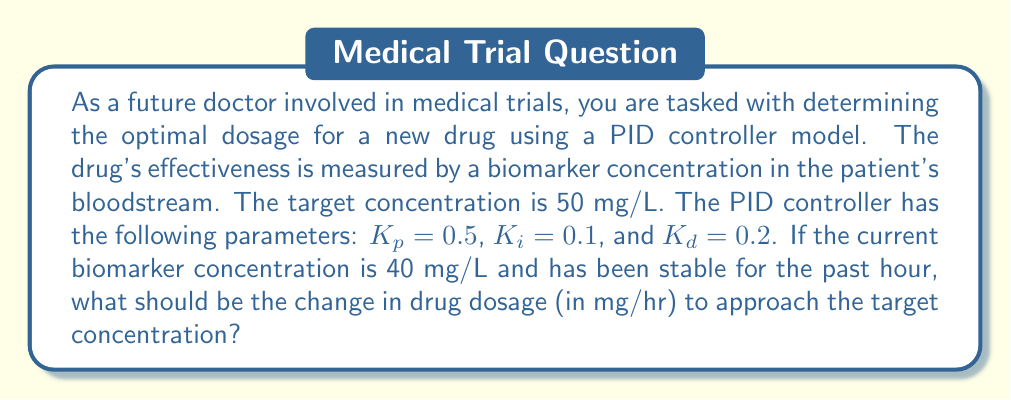Help me with this question. To solve this problem, we need to use the PID controller equation:

$$u(t) = K_p e(t) + K_i \int_0^t e(\tau) d\tau + K_d \frac{de(t)}{dt}$$

Where:
- $u(t)$ is the control output (change in drug dosage)
- $e(t)$ is the error (difference between target and current concentration)
- $K_p$, $K_i$, and $K_d$ are the proportional, integral, and derivative gains respectively

Let's break this down step-by-step:

1. Calculate the error:
   $e(t) = \text{Target concentration} - \text{Current concentration}$
   $e(t) = 50 \text{ mg/L} - 40 \text{ mg/L} = 10 \text{ mg/L}$

2. For the integral term, since the concentration has been stable for the past hour, we can approximate the integral as:
   $\int_0^t e(\tau) d\tau \approx e(t) \times 1 \text{ hour} = 10 \text{ mg/L} \cdot \text{hr}$

3. For the derivative term, since the concentration has been stable, the rate of change is zero:
   $\frac{de(t)}{dt} = 0$

Now, let's plug these values into the PID equation:

$$\begin{align*}
u(t) &= K_p e(t) + K_i \int_0^t e(\tau) d\tau + K_d \frac{de(t)}{dt} \\
&= 0.5 \times 10 + 0.1 \times 10 + 0.2 \times 0 \\
&= 5 + 1 + 0 \\
&= 6 \text{ mg/hr}
\end{align*}$$

Therefore, the PID controller suggests increasing the drug dosage by 6 mg/hr to approach the target concentration.
Answer: The change in drug dosage should be an increase of 6 mg/hr. 